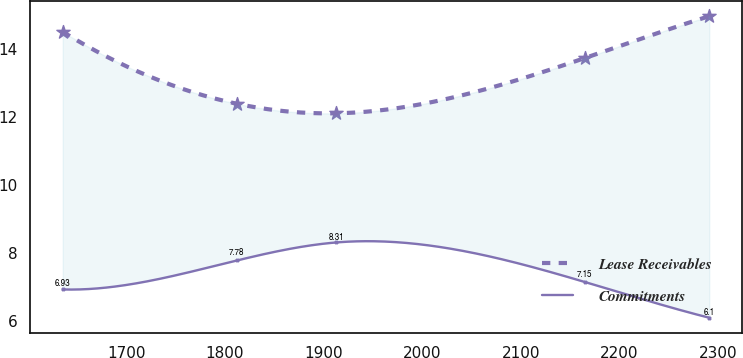Convert chart. <chart><loc_0><loc_0><loc_500><loc_500><line_chart><ecel><fcel>Lease Receivables<fcel>Commitments<nl><fcel>1635.29<fcel>14.49<fcel>6.93<nl><fcel>1811.96<fcel>12.38<fcel>7.78<nl><fcel>1913.1<fcel>12.1<fcel>8.31<nl><fcel>2165.04<fcel>13.72<fcel>7.15<nl><fcel>2291.45<fcel>14.95<fcel>6.1<nl></chart> 